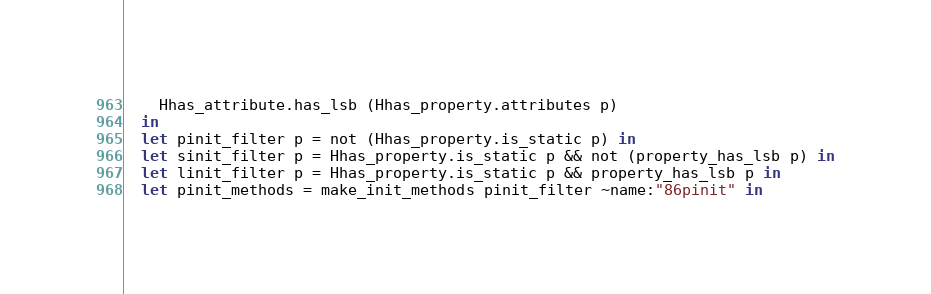Convert code to text. <code><loc_0><loc_0><loc_500><loc_500><_OCaml_>    Hhas_attribute.has_lsb (Hhas_property.attributes p)
  in
  let pinit_filter p = not (Hhas_property.is_static p) in
  let sinit_filter p = Hhas_property.is_static p && not (property_has_lsb p) in
  let linit_filter p = Hhas_property.is_static p && property_has_lsb p in
  let pinit_methods = make_init_methods pinit_filter ~name:"86pinit" in</code> 